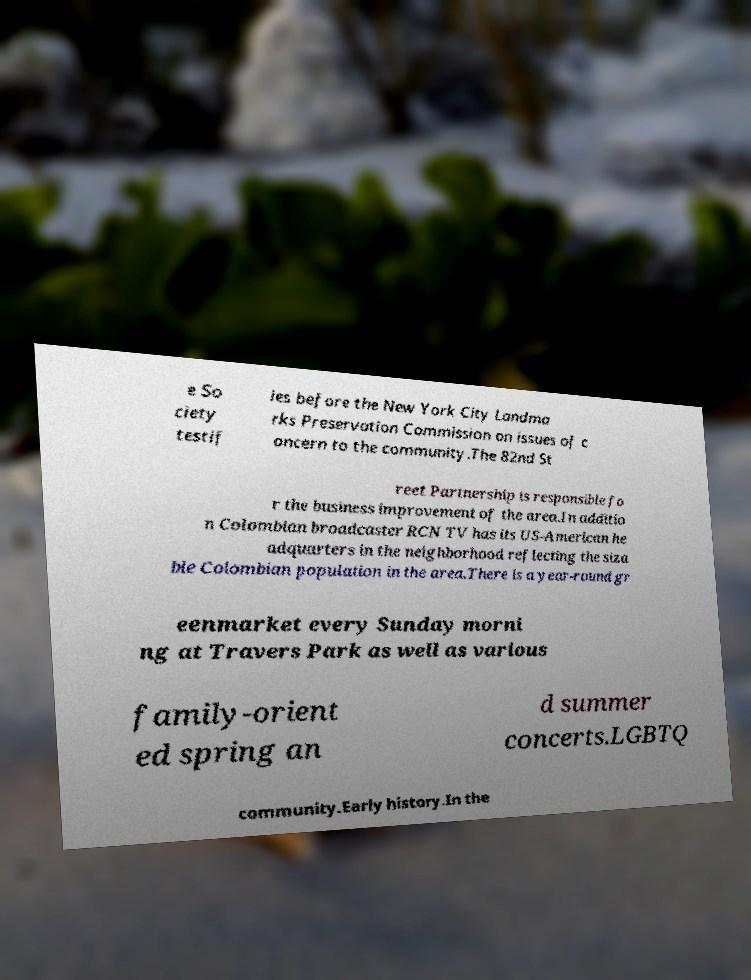Can you read and provide the text displayed in the image?This photo seems to have some interesting text. Can you extract and type it out for me? e So ciety testif ies before the New York City Landma rks Preservation Commission on issues of c oncern to the community.The 82nd St reet Partnership is responsible fo r the business improvement of the area.In additio n Colombian broadcaster RCN TV has its US-American he adquarters in the neighborhood reflecting the siza ble Colombian population in the area.There is a year-round gr eenmarket every Sunday morni ng at Travers Park as well as various family-orient ed spring an d summer concerts.LGBTQ community.Early history.In the 